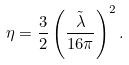<formula> <loc_0><loc_0><loc_500><loc_500>\eta = \frac { 3 } { 2 } \left ( \frac { \tilde { \lambda } } { 1 6 \pi } \right ) ^ { 2 } .</formula> 